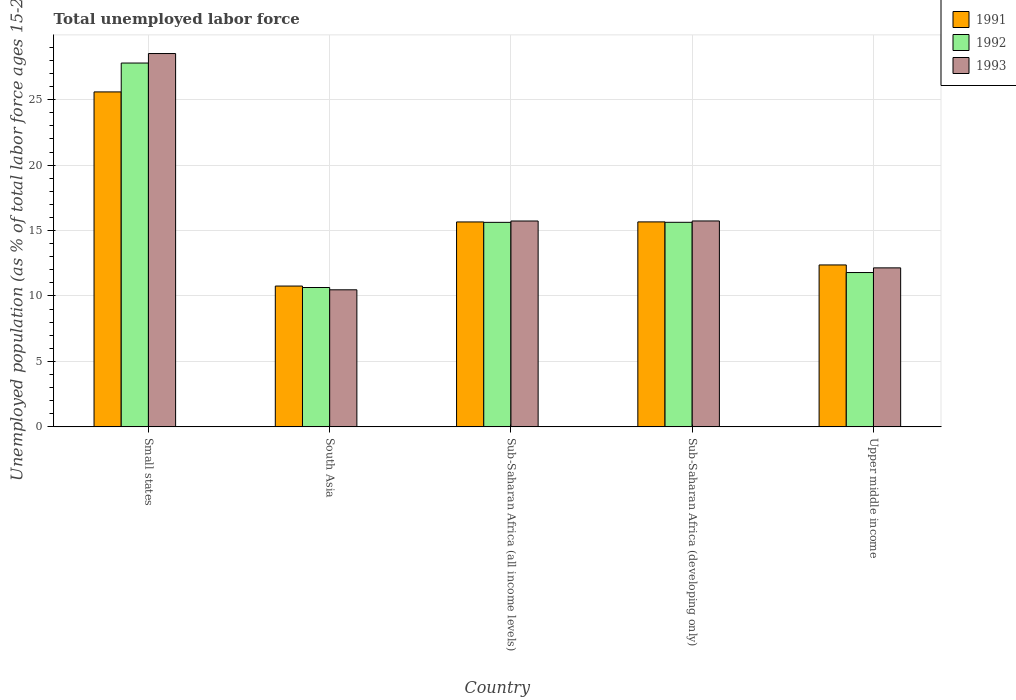How many different coloured bars are there?
Provide a short and direct response. 3. How many groups of bars are there?
Ensure brevity in your answer.  5. Are the number of bars on each tick of the X-axis equal?
Your response must be concise. Yes. How many bars are there on the 1st tick from the left?
Make the answer very short. 3. What is the label of the 3rd group of bars from the left?
Give a very brief answer. Sub-Saharan Africa (all income levels). What is the percentage of unemployed population in in 1993 in Sub-Saharan Africa (all income levels)?
Offer a very short reply. 15.73. Across all countries, what is the maximum percentage of unemployed population in in 1991?
Offer a very short reply. 25.59. Across all countries, what is the minimum percentage of unemployed population in in 1993?
Offer a very short reply. 10.47. In which country was the percentage of unemployed population in in 1991 maximum?
Ensure brevity in your answer.  Small states. In which country was the percentage of unemployed population in in 1992 minimum?
Keep it short and to the point. South Asia. What is the total percentage of unemployed population in in 1993 in the graph?
Your answer should be compact. 82.6. What is the difference between the percentage of unemployed population in in 1993 in Small states and that in South Asia?
Keep it short and to the point. 18.05. What is the difference between the percentage of unemployed population in in 1992 in Sub-Saharan Africa (all income levels) and the percentage of unemployed population in in 1993 in Small states?
Offer a terse response. -12.9. What is the average percentage of unemployed population in in 1992 per country?
Offer a terse response. 16.3. What is the difference between the percentage of unemployed population in of/in 1992 and percentage of unemployed population in of/in 1993 in Small states?
Provide a succinct answer. -0.73. What is the ratio of the percentage of unemployed population in in 1993 in Small states to that in South Asia?
Offer a very short reply. 2.72. Is the percentage of unemployed population in in 1991 in Sub-Saharan Africa (all income levels) less than that in Sub-Saharan Africa (developing only)?
Offer a terse response. Yes. What is the difference between the highest and the second highest percentage of unemployed population in in 1991?
Give a very brief answer. 9.93. What is the difference between the highest and the lowest percentage of unemployed population in in 1993?
Give a very brief answer. 18.05. In how many countries, is the percentage of unemployed population in in 1993 greater than the average percentage of unemployed population in in 1993 taken over all countries?
Offer a terse response. 1. Is the sum of the percentage of unemployed population in in 1992 in Small states and Upper middle income greater than the maximum percentage of unemployed population in in 1991 across all countries?
Your response must be concise. Yes. What does the 3rd bar from the left in Upper middle income represents?
Give a very brief answer. 1993. Is it the case that in every country, the sum of the percentage of unemployed population in in 1993 and percentage of unemployed population in in 1991 is greater than the percentage of unemployed population in in 1992?
Offer a terse response. Yes. How many bars are there?
Offer a very short reply. 15. Are all the bars in the graph horizontal?
Give a very brief answer. No. How many countries are there in the graph?
Give a very brief answer. 5. What is the difference between two consecutive major ticks on the Y-axis?
Ensure brevity in your answer.  5. Are the values on the major ticks of Y-axis written in scientific E-notation?
Ensure brevity in your answer.  No. Does the graph contain grids?
Make the answer very short. Yes. Where does the legend appear in the graph?
Give a very brief answer. Top right. How many legend labels are there?
Make the answer very short. 3. How are the legend labels stacked?
Provide a succinct answer. Vertical. What is the title of the graph?
Provide a short and direct response. Total unemployed labor force. Does "2011" appear as one of the legend labels in the graph?
Provide a short and direct response. No. What is the label or title of the Y-axis?
Your answer should be compact. Unemployed population (as % of total labor force ages 15-24). What is the Unemployed population (as % of total labor force ages 15-24) in 1991 in Small states?
Your answer should be compact. 25.59. What is the Unemployed population (as % of total labor force ages 15-24) in 1992 in Small states?
Give a very brief answer. 27.8. What is the Unemployed population (as % of total labor force ages 15-24) in 1993 in Small states?
Your answer should be very brief. 28.52. What is the Unemployed population (as % of total labor force ages 15-24) in 1991 in South Asia?
Your answer should be very brief. 10.76. What is the Unemployed population (as % of total labor force ages 15-24) of 1992 in South Asia?
Give a very brief answer. 10.65. What is the Unemployed population (as % of total labor force ages 15-24) in 1993 in South Asia?
Provide a succinct answer. 10.47. What is the Unemployed population (as % of total labor force ages 15-24) of 1991 in Sub-Saharan Africa (all income levels)?
Your answer should be very brief. 15.66. What is the Unemployed population (as % of total labor force ages 15-24) in 1992 in Sub-Saharan Africa (all income levels)?
Keep it short and to the point. 15.63. What is the Unemployed population (as % of total labor force ages 15-24) in 1993 in Sub-Saharan Africa (all income levels)?
Offer a very short reply. 15.73. What is the Unemployed population (as % of total labor force ages 15-24) in 1991 in Sub-Saharan Africa (developing only)?
Ensure brevity in your answer.  15.66. What is the Unemployed population (as % of total labor force ages 15-24) in 1992 in Sub-Saharan Africa (developing only)?
Give a very brief answer. 15.63. What is the Unemployed population (as % of total labor force ages 15-24) in 1993 in Sub-Saharan Africa (developing only)?
Your answer should be compact. 15.73. What is the Unemployed population (as % of total labor force ages 15-24) in 1991 in Upper middle income?
Your response must be concise. 12.37. What is the Unemployed population (as % of total labor force ages 15-24) in 1992 in Upper middle income?
Ensure brevity in your answer.  11.79. What is the Unemployed population (as % of total labor force ages 15-24) of 1993 in Upper middle income?
Your answer should be compact. 12.15. Across all countries, what is the maximum Unemployed population (as % of total labor force ages 15-24) in 1991?
Your response must be concise. 25.59. Across all countries, what is the maximum Unemployed population (as % of total labor force ages 15-24) in 1992?
Your answer should be compact. 27.8. Across all countries, what is the maximum Unemployed population (as % of total labor force ages 15-24) in 1993?
Offer a very short reply. 28.52. Across all countries, what is the minimum Unemployed population (as % of total labor force ages 15-24) in 1991?
Your answer should be very brief. 10.76. Across all countries, what is the minimum Unemployed population (as % of total labor force ages 15-24) in 1992?
Your answer should be very brief. 10.65. Across all countries, what is the minimum Unemployed population (as % of total labor force ages 15-24) of 1993?
Offer a very short reply. 10.47. What is the total Unemployed population (as % of total labor force ages 15-24) in 1991 in the graph?
Provide a short and direct response. 80.04. What is the total Unemployed population (as % of total labor force ages 15-24) in 1992 in the graph?
Your answer should be compact. 81.49. What is the total Unemployed population (as % of total labor force ages 15-24) of 1993 in the graph?
Your answer should be very brief. 82.6. What is the difference between the Unemployed population (as % of total labor force ages 15-24) in 1991 in Small states and that in South Asia?
Make the answer very short. 14.83. What is the difference between the Unemployed population (as % of total labor force ages 15-24) in 1992 in Small states and that in South Asia?
Ensure brevity in your answer.  17.15. What is the difference between the Unemployed population (as % of total labor force ages 15-24) of 1993 in Small states and that in South Asia?
Offer a very short reply. 18.05. What is the difference between the Unemployed population (as % of total labor force ages 15-24) of 1991 in Small states and that in Sub-Saharan Africa (all income levels)?
Keep it short and to the point. 9.93. What is the difference between the Unemployed population (as % of total labor force ages 15-24) of 1992 in Small states and that in Sub-Saharan Africa (all income levels)?
Give a very brief answer. 12.17. What is the difference between the Unemployed population (as % of total labor force ages 15-24) in 1993 in Small states and that in Sub-Saharan Africa (all income levels)?
Your answer should be compact. 12.79. What is the difference between the Unemployed population (as % of total labor force ages 15-24) of 1991 in Small states and that in Sub-Saharan Africa (developing only)?
Your answer should be very brief. 9.93. What is the difference between the Unemployed population (as % of total labor force ages 15-24) of 1992 in Small states and that in Sub-Saharan Africa (developing only)?
Make the answer very short. 12.17. What is the difference between the Unemployed population (as % of total labor force ages 15-24) in 1993 in Small states and that in Sub-Saharan Africa (developing only)?
Offer a terse response. 12.79. What is the difference between the Unemployed population (as % of total labor force ages 15-24) of 1991 in Small states and that in Upper middle income?
Give a very brief answer. 13.22. What is the difference between the Unemployed population (as % of total labor force ages 15-24) of 1992 in Small states and that in Upper middle income?
Offer a terse response. 16. What is the difference between the Unemployed population (as % of total labor force ages 15-24) in 1993 in Small states and that in Upper middle income?
Provide a short and direct response. 16.37. What is the difference between the Unemployed population (as % of total labor force ages 15-24) of 1991 in South Asia and that in Sub-Saharan Africa (all income levels)?
Make the answer very short. -4.9. What is the difference between the Unemployed population (as % of total labor force ages 15-24) in 1992 in South Asia and that in Sub-Saharan Africa (all income levels)?
Your answer should be compact. -4.98. What is the difference between the Unemployed population (as % of total labor force ages 15-24) in 1993 in South Asia and that in Sub-Saharan Africa (all income levels)?
Give a very brief answer. -5.26. What is the difference between the Unemployed population (as % of total labor force ages 15-24) of 1991 in South Asia and that in Sub-Saharan Africa (developing only)?
Your answer should be very brief. -4.9. What is the difference between the Unemployed population (as % of total labor force ages 15-24) in 1992 in South Asia and that in Sub-Saharan Africa (developing only)?
Keep it short and to the point. -4.98. What is the difference between the Unemployed population (as % of total labor force ages 15-24) in 1993 in South Asia and that in Sub-Saharan Africa (developing only)?
Your answer should be very brief. -5.26. What is the difference between the Unemployed population (as % of total labor force ages 15-24) of 1991 in South Asia and that in Upper middle income?
Keep it short and to the point. -1.61. What is the difference between the Unemployed population (as % of total labor force ages 15-24) in 1992 in South Asia and that in Upper middle income?
Offer a terse response. -1.14. What is the difference between the Unemployed population (as % of total labor force ages 15-24) of 1993 in South Asia and that in Upper middle income?
Make the answer very short. -1.68. What is the difference between the Unemployed population (as % of total labor force ages 15-24) of 1991 in Sub-Saharan Africa (all income levels) and that in Sub-Saharan Africa (developing only)?
Give a very brief answer. -0. What is the difference between the Unemployed population (as % of total labor force ages 15-24) of 1992 in Sub-Saharan Africa (all income levels) and that in Sub-Saharan Africa (developing only)?
Provide a short and direct response. -0. What is the difference between the Unemployed population (as % of total labor force ages 15-24) in 1993 in Sub-Saharan Africa (all income levels) and that in Sub-Saharan Africa (developing only)?
Give a very brief answer. -0. What is the difference between the Unemployed population (as % of total labor force ages 15-24) of 1991 in Sub-Saharan Africa (all income levels) and that in Upper middle income?
Your answer should be very brief. 3.28. What is the difference between the Unemployed population (as % of total labor force ages 15-24) in 1992 in Sub-Saharan Africa (all income levels) and that in Upper middle income?
Your answer should be very brief. 3.83. What is the difference between the Unemployed population (as % of total labor force ages 15-24) in 1993 in Sub-Saharan Africa (all income levels) and that in Upper middle income?
Your response must be concise. 3.58. What is the difference between the Unemployed population (as % of total labor force ages 15-24) of 1991 in Sub-Saharan Africa (developing only) and that in Upper middle income?
Provide a succinct answer. 3.29. What is the difference between the Unemployed population (as % of total labor force ages 15-24) of 1992 in Sub-Saharan Africa (developing only) and that in Upper middle income?
Give a very brief answer. 3.84. What is the difference between the Unemployed population (as % of total labor force ages 15-24) of 1993 in Sub-Saharan Africa (developing only) and that in Upper middle income?
Give a very brief answer. 3.58. What is the difference between the Unemployed population (as % of total labor force ages 15-24) in 1991 in Small states and the Unemployed population (as % of total labor force ages 15-24) in 1992 in South Asia?
Give a very brief answer. 14.94. What is the difference between the Unemployed population (as % of total labor force ages 15-24) of 1991 in Small states and the Unemployed population (as % of total labor force ages 15-24) of 1993 in South Asia?
Your answer should be very brief. 15.12. What is the difference between the Unemployed population (as % of total labor force ages 15-24) in 1992 in Small states and the Unemployed population (as % of total labor force ages 15-24) in 1993 in South Asia?
Your response must be concise. 17.32. What is the difference between the Unemployed population (as % of total labor force ages 15-24) in 1991 in Small states and the Unemployed population (as % of total labor force ages 15-24) in 1992 in Sub-Saharan Africa (all income levels)?
Keep it short and to the point. 9.97. What is the difference between the Unemployed population (as % of total labor force ages 15-24) in 1991 in Small states and the Unemployed population (as % of total labor force ages 15-24) in 1993 in Sub-Saharan Africa (all income levels)?
Provide a succinct answer. 9.86. What is the difference between the Unemployed population (as % of total labor force ages 15-24) in 1992 in Small states and the Unemployed population (as % of total labor force ages 15-24) in 1993 in Sub-Saharan Africa (all income levels)?
Provide a short and direct response. 12.07. What is the difference between the Unemployed population (as % of total labor force ages 15-24) of 1991 in Small states and the Unemployed population (as % of total labor force ages 15-24) of 1992 in Sub-Saharan Africa (developing only)?
Your response must be concise. 9.96. What is the difference between the Unemployed population (as % of total labor force ages 15-24) of 1991 in Small states and the Unemployed population (as % of total labor force ages 15-24) of 1993 in Sub-Saharan Africa (developing only)?
Give a very brief answer. 9.86. What is the difference between the Unemployed population (as % of total labor force ages 15-24) in 1992 in Small states and the Unemployed population (as % of total labor force ages 15-24) in 1993 in Sub-Saharan Africa (developing only)?
Give a very brief answer. 12.06. What is the difference between the Unemployed population (as % of total labor force ages 15-24) in 1991 in Small states and the Unemployed population (as % of total labor force ages 15-24) in 1992 in Upper middle income?
Make the answer very short. 13.8. What is the difference between the Unemployed population (as % of total labor force ages 15-24) in 1991 in Small states and the Unemployed population (as % of total labor force ages 15-24) in 1993 in Upper middle income?
Provide a succinct answer. 13.44. What is the difference between the Unemployed population (as % of total labor force ages 15-24) in 1992 in Small states and the Unemployed population (as % of total labor force ages 15-24) in 1993 in Upper middle income?
Keep it short and to the point. 15.65. What is the difference between the Unemployed population (as % of total labor force ages 15-24) in 1991 in South Asia and the Unemployed population (as % of total labor force ages 15-24) in 1992 in Sub-Saharan Africa (all income levels)?
Ensure brevity in your answer.  -4.87. What is the difference between the Unemployed population (as % of total labor force ages 15-24) of 1991 in South Asia and the Unemployed population (as % of total labor force ages 15-24) of 1993 in Sub-Saharan Africa (all income levels)?
Give a very brief answer. -4.97. What is the difference between the Unemployed population (as % of total labor force ages 15-24) in 1992 in South Asia and the Unemployed population (as % of total labor force ages 15-24) in 1993 in Sub-Saharan Africa (all income levels)?
Provide a short and direct response. -5.08. What is the difference between the Unemployed population (as % of total labor force ages 15-24) in 1991 in South Asia and the Unemployed population (as % of total labor force ages 15-24) in 1992 in Sub-Saharan Africa (developing only)?
Keep it short and to the point. -4.87. What is the difference between the Unemployed population (as % of total labor force ages 15-24) in 1991 in South Asia and the Unemployed population (as % of total labor force ages 15-24) in 1993 in Sub-Saharan Africa (developing only)?
Offer a very short reply. -4.97. What is the difference between the Unemployed population (as % of total labor force ages 15-24) of 1992 in South Asia and the Unemployed population (as % of total labor force ages 15-24) of 1993 in Sub-Saharan Africa (developing only)?
Keep it short and to the point. -5.08. What is the difference between the Unemployed population (as % of total labor force ages 15-24) in 1991 in South Asia and the Unemployed population (as % of total labor force ages 15-24) in 1992 in Upper middle income?
Provide a succinct answer. -1.03. What is the difference between the Unemployed population (as % of total labor force ages 15-24) in 1991 in South Asia and the Unemployed population (as % of total labor force ages 15-24) in 1993 in Upper middle income?
Keep it short and to the point. -1.39. What is the difference between the Unemployed population (as % of total labor force ages 15-24) of 1992 in South Asia and the Unemployed population (as % of total labor force ages 15-24) of 1993 in Upper middle income?
Provide a short and direct response. -1.5. What is the difference between the Unemployed population (as % of total labor force ages 15-24) of 1991 in Sub-Saharan Africa (all income levels) and the Unemployed population (as % of total labor force ages 15-24) of 1992 in Sub-Saharan Africa (developing only)?
Make the answer very short. 0.03. What is the difference between the Unemployed population (as % of total labor force ages 15-24) of 1991 in Sub-Saharan Africa (all income levels) and the Unemployed population (as % of total labor force ages 15-24) of 1993 in Sub-Saharan Africa (developing only)?
Your answer should be very brief. -0.08. What is the difference between the Unemployed population (as % of total labor force ages 15-24) in 1992 in Sub-Saharan Africa (all income levels) and the Unemployed population (as % of total labor force ages 15-24) in 1993 in Sub-Saharan Africa (developing only)?
Your answer should be compact. -0.11. What is the difference between the Unemployed population (as % of total labor force ages 15-24) of 1991 in Sub-Saharan Africa (all income levels) and the Unemployed population (as % of total labor force ages 15-24) of 1992 in Upper middle income?
Keep it short and to the point. 3.86. What is the difference between the Unemployed population (as % of total labor force ages 15-24) in 1991 in Sub-Saharan Africa (all income levels) and the Unemployed population (as % of total labor force ages 15-24) in 1993 in Upper middle income?
Give a very brief answer. 3.51. What is the difference between the Unemployed population (as % of total labor force ages 15-24) in 1992 in Sub-Saharan Africa (all income levels) and the Unemployed population (as % of total labor force ages 15-24) in 1993 in Upper middle income?
Your answer should be very brief. 3.48. What is the difference between the Unemployed population (as % of total labor force ages 15-24) of 1991 in Sub-Saharan Africa (developing only) and the Unemployed population (as % of total labor force ages 15-24) of 1992 in Upper middle income?
Ensure brevity in your answer.  3.87. What is the difference between the Unemployed population (as % of total labor force ages 15-24) of 1991 in Sub-Saharan Africa (developing only) and the Unemployed population (as % of total labor force ages 15-24) of 1993 in Upper middle income?
Give a very brief answer. 3.51. What is the difference between the Unemployed population (as % of total labor force ages 15-24) of 1992 in Sub-Saharan Africa (developing only) and the Unemployed population (as % of total labor force ages 15-24) of 1993 in Upper middle income?
Your response must be concise. 3.48. What is the average Unemployed population (as % of total labor force ages 15-24) of 1991 per country?
Offer a very short reply. 16.01. What is the average Unemployed population (as % of total labor force ages 15-24) in 1992 per country?
Provide a short and direct response. 16.3. What is the average Unemployed population (as % of total labor force ages 15-24) in 1993 per country?
Your response must be concise. 16.52. What is the difference between the Unemployed population (as % of total labor force ages 15-24) of 1991 and Unemployed population (as % of total labor force ages 15-24) of 1992 in Small states?
Offer a very short reply. -2.21. What is the difference between the Unemployed population (as % of total labor force ages 15-24) of 1991 and Unemployed population (as % of total labor force ages 15-24) of 1993 in Small states?
Your answer should be compact. -2.93. What is the difference between the Unemployed population (as % of total labor force ages 15-24) of 1992 and Unemployed population (as % of total labor force ages 15-24) of 1993 in Small states?
Ensure brevity in your answer.  -0.73. What is the difference between the Unemployed population (as % of total labor force ages 15-24) in 1991 and Unemployed population (as % of total labor force ages 15-24) in 1992 in South Asia?
Offer a terse response. 0.11. What is the difference between the Unemployed population (as % of total labor force ages 15-24) of 1991 and Unemployed population (as % of total labor force ages 15-24) of 1993 in South Asia?
Ensure brevity in your answer.  0.29. What is the difference between the Unemployed population (as % of total labor force ages 15-24) of 1992 and Unemployed population (as % of total labor force ages 15-24) of 1993 in South Asia?
Offer a very short reply. 0.18. What is the difference between the Unemployed population (as % of total labor force ages 15-24) in 1991 and Unemployed population (as % of total labor force ages 15-24) in 1992 in Sub-Saharan Africa (all income levels)?
Ensure brevity in your answer.  0.03. What is the difference between the Unemployed population (as % of total labor force ages 15-24) of 1991 and Unemployed population (as % of total labor force ages 15-24) of 1993 in Sub-Saharan Africa (all income levels)?
Your answer should be very brief. -0.07. What is the difference between the Unemployed population (as % of total labor force ages 15-24) of 1992 and Unemployed population (as % of total labor force ages 15-24) of 1993 in Sub-Saharan Africa (all income levels)?
Give a very brief answer. -0.1. What is the difference between the Unemployed population (as % of total labor force ages 15-24) of 1991 and Unemployed population (as % of total labor force ages 15-24) of 1992 in Sub-Saharan Africa (developing only)?
Offer a terse response. 0.03. What is the difference between the Unemployed population (as % of total labor force ages 15-24) in 1991 and Unemployed population (as % of total labor force ages 15-24) in 1993 in Sub-Saharan Africa (developing only)?
Keep it short and to the point. -0.07. What is the difference between the Unemployed population (as % of total labor force ages 15-24) of 1992 and Unemployed population (as % of total labor force ages 15-24) of 1993 in Sub-Saharan Africa (developing only)?
Offer a very short reply. -0.1. What is the difference between the Unemployed population (as % of total labor force ages 15-24) of 1991 and Unemployed population (as % of total labor force ages 15-24) of 1992 in Upper middle income?
Your answer should be very brief. 0.58. What is the difference between the Unemployed population (as % of total labor force ages 15-24) of 1991 and Unemployed population (as % of total labor force ages 15-24) of 1993 in Upper middle income?
Your answer should be compact. 0.22. What is the difference between the Unemployed population (as % of total labor force ages 15-24) in 1992 and Unemployed population (as % of total labor force ages 15-24) in 1993 in Upper middle income?
Ensure brevity in your answer.  -0.36. What is the ratio of the Unemployed population (as % of total labor force ages 15-24) of 1991 in Small states to that in South Asia?
Give a very brief answer. 2.38. What is the ratio of the Unemployed population (as % of total labor force ages 15-24) of 1992 in Small states to that in South Asia?
Give a very brief answer. 2.61. What is the ratio of the Unemployed population (as % of total labor force ages 15-24) of 1993 in Small states to that in South Asia?
Provide a short and direct response. 2.72. What is the ratio of the Unemployed population (as % of total labor force ages 15-24) in 1991 in Small states to that in Sub-Saharan Africa (all income levels)?
Offer a very short reply. 1.63. What is the ratio of the Unemployed population (as % of total labor force ages 15-24) of 1992 in Small states to that in Sub-Saharan Africa (all income levels)?
Ensure brevity in your answer.  1.78. What is the ratio of the Unemployed population (as % of total labor force ages 15-24) of 1993 in Small states to that in Sub-Saharan Africa (all income levels)?
Your response must be concise. 1.81. What is the ratio of the Unemployed population (as % of total labor force ages 15-24) in 1991 in Small states to that in Sub-Saharan Africa (developing only)?
Offer a terse response. 1.63. What is the ratio of the Unemployed population (as % of total labor force ages 15-24) in 1992 in Small states to that in Sub-Saharan Africa (developing only)?
Keep it short and to the point. 1.78. What is the ratio of the Unemployed population (as % of total labor force ages 15-24) in 1993 in Small states to that in Sub-Saharan Africa (developing only)?
Keep it short and to the point. 1.81. What is the ratio of the Unemployed population (as % of total labor force ages 15-24) of 1991 in Small states to that in Upper middle income?
Your answer should be very brief. 2.07. What is the ratio of the Unemployed population (as % of total labor force ages 15-24) of 1992 in Small states to that in Upper middle income?
Your answer should be compact. 2.36. What is the ratio of the Unemployed population (as % of total labor force ages 15-24) in 1993 in Small states to that in Upper middle income?
Offer a terse response. 2.35. What is the ratio of the Unemployed population (as % of total labor force ages 15-24) in 1991 in South Asia to that in Sub-Saharan Africa (all income levels)?
Your response must be concise. 0.69. What is the ratio of the Unemployed population (as % of total labor force ages 15-24) in 1992 in South Asia to that in Sub-Saharan Africa (all income levels)?
Give a very brief answer. 0.68. What is the ratio of the Unemployed population (as % of total labor force ages 15-24) of 1993 in South Asia to that in Sub-Saharan Africa (all income levels)?
Provide a succinct answer. 0.67. What is the ratio of the Unemployed population (as % of total labor force ages 15-24) of 1991 in South Asia to that in Sub-Saharan Africa (developing only)?
Provide a short and direct response. 0.69. What is the ratio of the Unemployed population (as % of total labor force ages 15-24) in 1992 in South Asia to that in Sub-Saharan Africa (developing only)?
Your answer should be compact. 0.68. What is the ratio of the Unemployed population (as % of total labor force ages 15-24) of 1993 in South Asia to that in Sub-Saharan Africa (developing only)?
Offer a terse response. 0.67. What is the ratio of the Unemployed population (as % of total labor force ages 15-24) in 1991 in South Asia to that in Upper middle income?
Provide a succinct answer. 0.87. What is the ratio of the Unemployed population (as % of total labor force ages 15-24) in 1992 in South Asia to that in Upper middle income?
Offer a terse response. 0.9. What is the ratio of the Unemployed population (as % of total labor force ages 15-24) in 1993 in South Asia to that in Upper middle income?
Your answer should be very brief. 0.86. What is the ratio of the Unemployed population (as % of total labor force ages 15-24) in 1991 in Sub-Saharan Africa (all income levels) to that in Sub-Saharan Africa (developing only)?
Offer a terse response. 1. What is the ratio of the Unemployed population (as % of total labor force ages 15-24) of 1993 in Sub-Saharan Africa (all income levels) to that in Sub-Saharan Africa (developing only)?
Make the answer very short. 1. What is the ratio of the Unemployed population (as % of total labor force ages 15-24) in 1991 in Sub-Saharan Africa (all income levels) to that in Upper middle income?
Keep it short and to the point. 1.27. What is the ratio of the Unemployed population (as % of total labor force ages 15-24) in 1992 in Sub-Saharan Africa (all income levels) to that in Upper middle income?
Provide a succinct answer. 1.33. What is the ratio of the Unemployed population (as % of total labor force ages 15-24) in 1993 in Sub-Saharan Africa (all income levels) to that in Upper middle income?
Give a very brief answer. 1.29. What is the ratio of the Unemployed population (as % of total labor force ages 15-24) of 1991 in Sub-Saharan Africa (developing only) to that in Upper middle income?
Keep it short and to the point. 1.27. What is the ratio of the Unemployed population (as % of total labor force ages 15-24) in 1992 in Sub-Saharan Africa (developing only) to that in Upper middle income?
Make the answer very short. 1.33. What is the ratio of the Unemployed population (as % of total labor force ages 15-24) in 1993 in Sub-Saharan Africa (developing only) to that in Upper middle income?
Make the answer very short. 1.29. What is the difference between the highest and the second highest Unemployed population (as % of total labor force ages 15-24) in 1991?
Your answer should be very brief. 9.93. What is the difference between the highest and the second highest Unemployed population (as % of total labor force ages 15-24) of 1992?
Offer a terse response. 12.17. What is the difference between the highest and the second highest Unemployed population (as % of total labor force ages 15-24) in 1993?
Your answer should be very brief. 12.79. What is the difference between the highest and the lowest Unemployed population (as % of total labor force ages 15-24) in 1991?
Provide a succinct answer. 14.83. What is the difference between the highest and the lowest Unemployed population (as % of total labor force ages 15-24) of 1992?
Offer a very short reply. 17.15. What is the difference between the highest and the lowest Unemployed population (as % of total labor force ages 15-24) of 1993?
Provide a succinct answer. 18.05. 